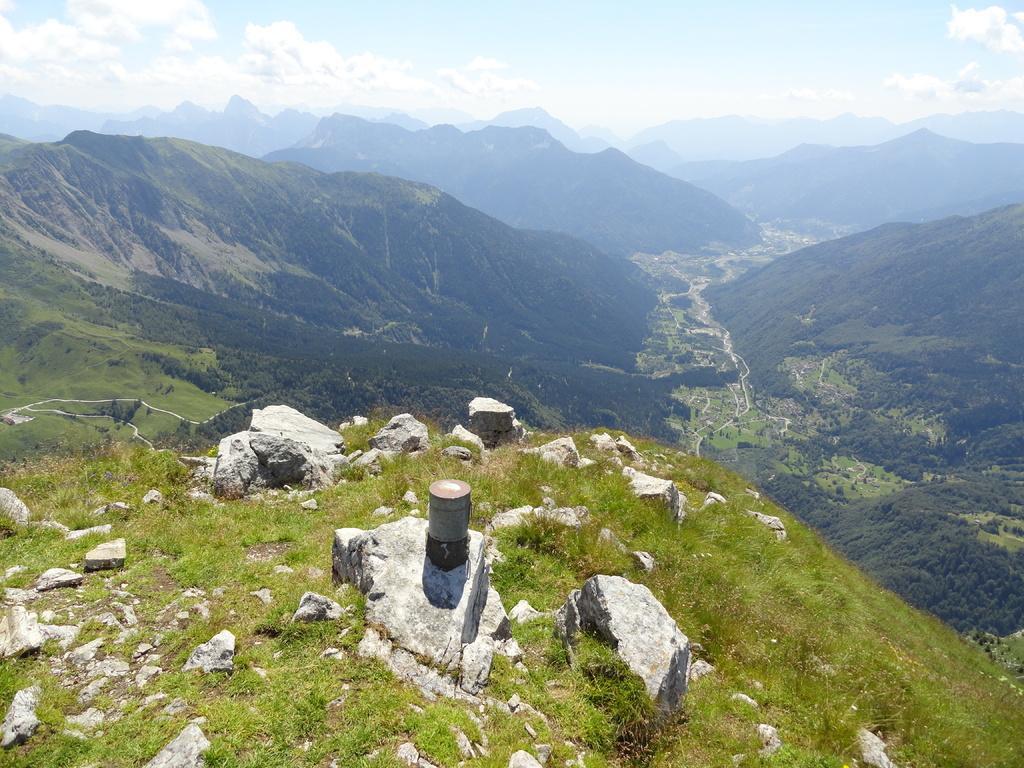Can you describe this image briefly? In this image we can see many forest mountains. There is a slightly cloudy and blue sky at the top most of the image and grassy land at the bottom of the image. 